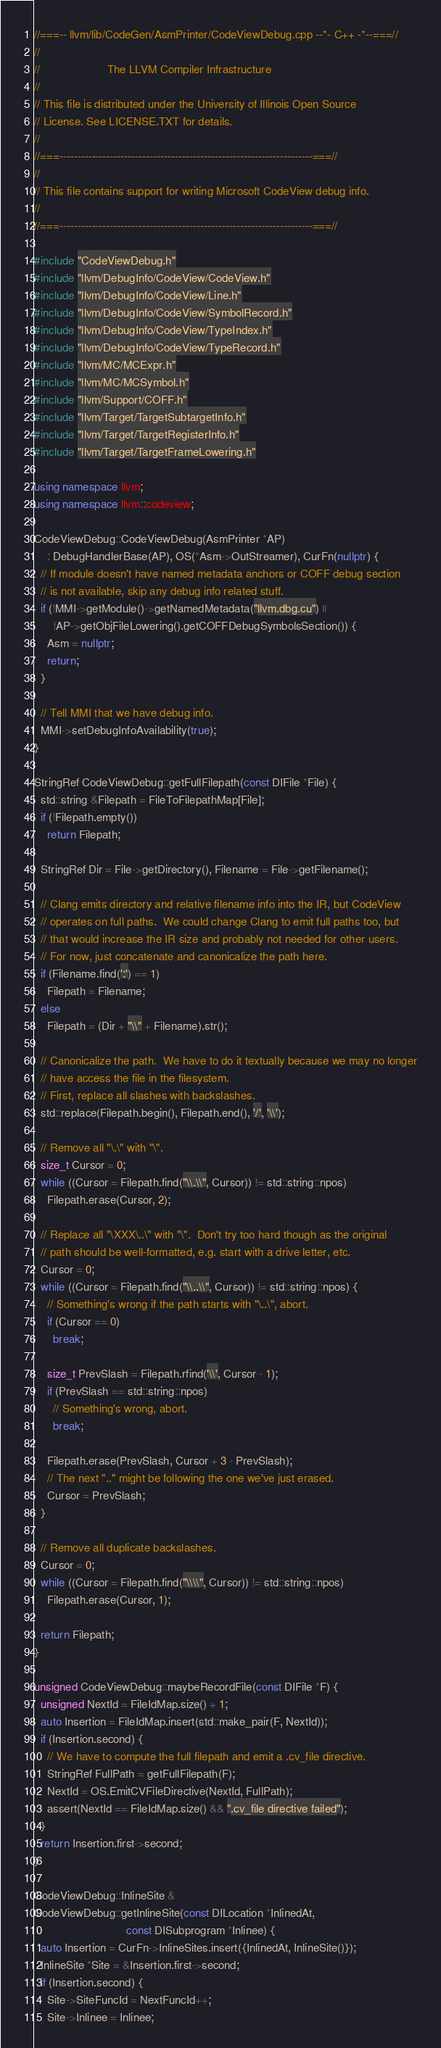Convert code to text. <code><loc_0><loc_0><loc_500><loc_500><_C++_>//===-- llvm/lib/CodeGen/AsmPrinter/CodeViewDebug.cpp --*- C++ -*--===//
//
//                     The LLVM Compiler Infrastructure
//
// This file is distributed under the University of Illinois Open Source
// License. See LICENSE.TXT for details.
//
//===----------------------------------------------------------------------===//
//
// This file contains support for writing Microsoft CodeView debug info.
//
//===----------------------------------------------------------------------===//

#include "CodeViewDebug.h"
#include "llvm/DebugInfo/CodeView/CodeView.h"
#include "llvm/DebugInfo/CodeView/Line.h"
#include "llvm/DebugInfo/CodeView/SymbolRecord.h"
#include "llvm/DebugInfo/CodeView/TypeIndex.h"
#include "llvm/DebugInfo/CodeView/TypeRecord.h"
#include "llvm/MC/MCExpr.h"
#include "llvm/MC/MCSymbol.h"
#include "llvm/Support/COFF.h"
#include "llvm/Target/TargetSubtargetInfo.h"
#include "llvm/Target/TargetRegisterInfo.h"
#include "llvm/Target/TargetFrameLowering.h"

using namespace llvm;
using namespace llvm::codeview;

CodeViewDebug::CodeViewDebug(AsmPrinter *AP)
    : DebugHandlerBase(AP), OS(*Asm->OutStreamer), CurFn(nullptr) {
  // If module doesn't have named metadata anchors or COFF debug section
  // is not available, skip any debug info related stuff.
  if (!MMI->getModule()->getNamedMetadata("llvm.dbg.cu") ||
      !AP->getObjFileLowering().getCOFFDebugSymbolsSection()) {
    Asm = nullptr;
    return;
  }

  // Tell MMI that we have debug info.
  MMI->setDebugInfoAvailability(true);
}

StringRef CodeViewDebug::getFullFilepath(const DIFile *File) {
  std::string &Filepath = FileToFilepathMap[File];
  if (!Filepath.empty())
    return Filepath;

  StringRef Dir = File->getDirectory(), Filename = File->getFilename();

  // Clang emits directory and relative filename info into the IR, but CodeView
  // operates on full paths.  We could change Clang to emit full paths too, but
  // that would increase the IR size and probably not needed for other users.
  // For now, just concatenate and canonicalize the path here.
  if (Filename.find(':') == 1)
    Filepath = Filename;
  else
    Filepath = (Dir + "\\" + Filename).str();

  // Canonicalize the path.  We have to do it textually because we may no longer
  // have access the file in the filesystem.
  // First, replace all slashes with backslashes.
  std::replace(Filepath.begin(), Filepath.end(), '/', '\\');

  // Remove all "\.\" with "\".
  size_t Cursor = 0;
  while ((Cursor = Filepath.find("\\.\\", Cursor)) != std::string::npos)
    Filepath.erase(Cursor, 2);

  // Replace all "\XXX\..\" with "\".  Don't try too hard though as the original
  // path should be well-formatted, e.g. start with a drive letter, etc.
  Cursor = 0;
  while ((Cursor = Filepath.find("\\..\\", Cursor)) != std::string::npos) {
    // Something's wrong if the path starts with "\..\", abort.
    if (Cursor == 0)
      break;

    size_t PrevSlash = Filepath.rfind('\\', Cursor - 1);
    if (PrevSlash == std::string::npos)
      // Something's wrong, abort.
      break;

    Filepath.erase(PrevSlash, Cursor + 3 - PrevSlash);
    // The next ".." might be following the one we've just erased.
    Cursor = PrevSlash;
  }

  // Remove all duplicate backslashes.
  Cursor = 0;
  while ((Cursor = Filepath.find("\\\\", Cursor)) != std::string::npos)
    Filepath.erase(Cursor, 1);

  return Filepath;
}

unsigned CodeViewDebug::maybeRecordFile(const DIFile *F) {
  unsigned NextId = FileIdMap.size() + 1;
  auto Insertion = FileIdMap.insert(std::make_pair(F, NextId));
  if (Insertion.second) {
    // We have to compute the full filepath and emit a .cv_file directive.
    StringRef FullPath = getFullFilepath(F);
    NextId = OS.EmitCVFileDirective(NextId, FullPath);
    assert(NextId == FileIdMap.size() && ".cv_file directive failed");
  }
  return Insertion.first->second;
}

CodeViewDebug::InlineSite &
CodeViewDebug::getInlineSite(const DILocation *InlinedAt,
                             const DISubprogram *Inlinee) {
  auto Insertion = CurFn->InlineSites.insert({InlinedAt, InlineSite()});
  InlineSite *Site = &Insertion.first->second;
  if (Insertion.second) {
    Site->SiteFuncId = NextFuncId++;
    Site->Inlinee = Inlinee;</code> 